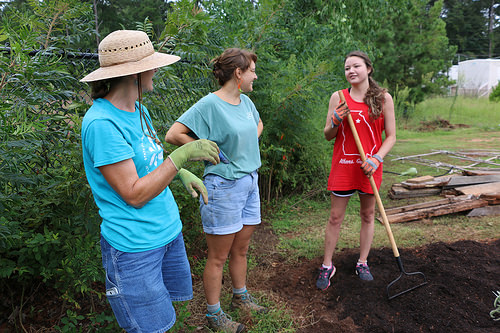<image>
Is the glove on the woman? No. The glove is not positioned on the woman. They may be near each other, but the glove is not supported by or resting on top of the woman. Where is the lady in relation to the lady? Is it on the lady? No. The lady is not positioned on the lady. They may be near each other, but the lady is not supported by or resting on top of the lady. Where is the hat in relation to the woman? Is it on the woman? No. The hat is not positioned on the woman. They may be near each other, but the hat is not supported by or resting on top of the woman. Is there a women to the left of the women? Yes. From this viewpoint, the women is positioned to the left side relative to the women. Is the woman behind the plant? No. The woman is not behind the plant. From this viewpoint, the woman appears to be positioned elsewhere in the scene. 